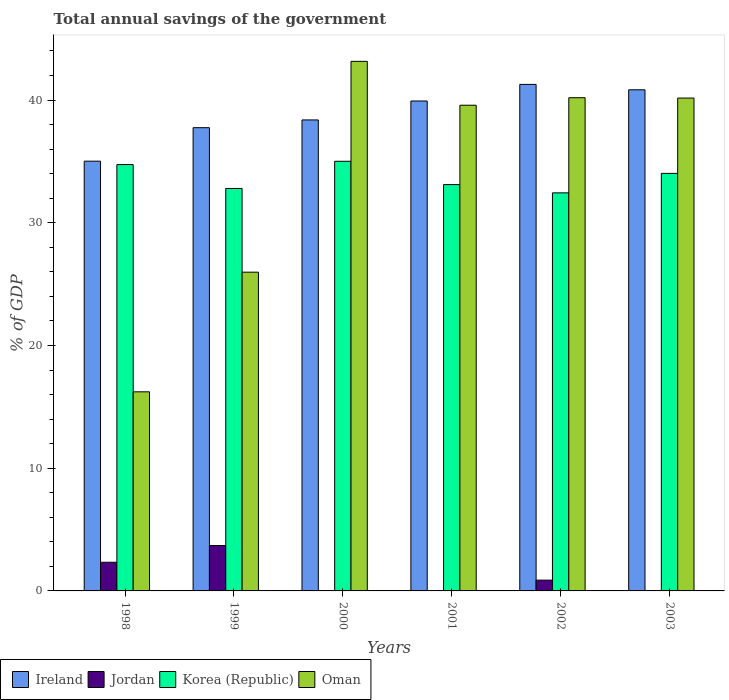How many different coloured bars are there?
Offer a very short reply. 4. How many groups of bars are there?
Make the answer very short. 6. Are the number of bars per tick equal to the number of legend labels?
Ensure brevity in your answer.  No. Are the number of bars on each tick of the X-axis equal?
Offer a very short reply. No. In how many cases, is the number of bars for a given year not equal to the number of legend labels?
Your response must be concise. 3. What is the total annual savings of the government in Oman in 2003?
Offer a very short reply. 40.16. Across all years, what is the maximum total annual savings of the government in Jordan?
Give a very brief answer. 3.7. What is the total total annual savings of the government in Korea (Republic) in the graph?
Ensure brevity in your answer.  202.13. What is the difference between the total annual savings of the government in Oman in 1998 and that in 2000?
Your answer should be compact. -26.93. What is the difference between the total annual savings of the government in Oman in 2003 and the total annual savings of the government in Jordan in 2001?
Your answer should be very brief. 40.16. What is the average total annual savings of the government in Ireland per year?
Your answer should be compact. 38.87. In the year 2002, what is the difference between the total annual savings of the government in Korea (Republic) and total annual savings of the government in Ireland?
Offer a very short reply. -8.84. What is the ratio of the total annual savings of the government in Korea (Republic) in 2000 to that in 2003?
Provide a succinct answer. 1.03. Is the total annual savings of the government in Ireland in 1999 less than that in 2000?
Offer a very short reply. Yes. What is the difference between the highest and the second highest total annual savings of the government in Korea (Republic)?
Provide a short and direct response. 0.27. What is the difference between the highest and the lowest total annual savings of the government in Ireland?
Keep it short and to the point. 6.26. Is it the case that in every year, the sum of the total annual savings of the government in Oman and total annual savings of the government in Jordan is greater than the sum of total annual savings of the government in Ireland and total annual savings of the government in Korea (Republic)?
Ensure brevity in your answer.  No. Is it the case that in every year, the sum of the total annual savings of the government in Korea (Republic) and total annual savings of the government in Jordan is greater than the total annual savings of the government in Oman?
Provide a short and direct response. No. How many bars are there?
Your answer should be very brief. 21. Are all the bars in the graph horizontal?
Provide a short and direct response. No. What is the difference between two consecutive major ticks on the Y-axis?
Your answer should be very brief. 10. Are the values on the major ticks of Y-axis written in scientific E-notation?
Provide a short and direct response. No. Does the graph contain grids?
Ensure brevity in your answer.  No. Where does the legend appear in the graph?
Your answer should be very brief. Bottom left. How many legend labels are there?
Provide a short and direct response. 4. What is the title of the graph?
Your answer should be very brief. Total annual savings of the government. Does "United States" appear as one of the legend labels in the graph?
Keep it short and to the point. No. What is the label or title of the Y-axis?
Provide a succinct answer. % of GDP. What is the % of GDP in Ireland in 1998?
Ensure brevity in your answer.  35.02. What is the % of GDP of Jordan in 1998?
Give a very brief answer. 2.34. What is the % of GDP in Korea (Republic) in 1998?
Your answer should be compact. 34.74. What is the % of GDP in Oman in 1998?
Your answer should be compact. 16.23. What is the % of GDP of Ireland in 1999?
Keep it short and to the point. 37.75. What is the % of GDP of Jordan in 1999?
Give a very brief answer. 3.7. What is the % of GDP of Korea (Republic) in 1999?
Give a very brief answer. 32.8. What is the % of GDP in Oman in 1999?
Your answer should be compact. 25.98. What is the % of GDP of Ireland in 2000?
Offer a very short reply. 38.38. What is the % of GDP of Korea (Republic) in 2000?
Your answer should be very brief. 35.01. What is the % of GDP in Oman in 2000?
Provide a succinct answer. 43.16. What is the % of GDP in Ireland in 2001?
Your response must be concise. 39.92. What is the % of GDP of Jordan in 2001?
Offer a terse response. 0. What is the % of GDP in Korea (Republic) in 2001?
Your response must be concise. 33.11. What is the % of GDP in Oman in 2001?
Offer a very short reply. 39.58. What is the % of GDP in Ireland in 2002?
Your response must be concise. 41.28. What is the % of GDP in Jordan in 2002?
Provide a succinct answer. 0.88. What is the % of GDP of Korea (Republic) in 2002?
Keep it short and to the point. 32.44. What is the % of GDP in Oman in 2002?
Your answer should be very brief. 40.19. What is the % of GDP in Ireland in 2003?
Offer a very short reply. 40.84. What is the % of GDP in Jordan in 2003?
Keep it short and to the point. 0. What is the % of GDP in Korea (Republic) in 2003?
Make the answer very short. 34.03. What is the % of GDP in Oman in 2003?
Provide a short and direct response. 40.16. Across all years, what is the maximum % of GDP of Ireland?
Offer a terse response. 41.28. Across all years, what is the maximum % of GDP in Jordan?
Offer a very short reply. 3.7. Across all years, what is the maximum % of GDP in Korea (Republic)?
Offer a terse response. 35.01. Across all years, what is the maximum % of GDP in Oman?
Your answer should be compact. 43.16. Across all years, what is the minimum % of GDP of Ireland?
Ensure brevity in your answer.  35.02. Across all years, what is the minimum % of GDP of Korea (Republic)?
Your answer should be compact. 32.44. Across all years, what is the minimum % of GDP of Oman?
Offer a terse response. 16.23. What is the total % of GDP in Ireland in the graph?
Your response must be concise. 233.19. What is the total % of GDP in Jordan in the graph?
Provide a short and direct response. 6.92. What is the total % of GDP of Korea (Republic) in the graph?
Your answer should be compact. 202.13. What is the total % of GDP of Oman in the graph?
Keep it short and to the point. 205.29. What is the difference between the % of GDP of Ireland in 1998 and that in 1999?
Provide a succinct answer. -2.73. What is the difference between the % of GDP in Jordan in 1998 and that in 1999?
Keep it short and to the point. -1.37. What is the difference between the % of GDP in Korea (Republic) in 1998 and that in 1999?
Provide a succinct answer. 1.95. What is the difference between the % of GDP in Oman in 1998 and that in 1999?
Offer a terse response. -9.75. What is the difference between the % of GDP in Ireland in 1998 and that in 2000?
Your answer should be compact. -3.36. What is the difference between the % of GDP in Korea (Republic) in 1998 and that in 2000?
Offer a very short reply. -0.27. What is the difference between the % of GDP in Oman in 1998 and that in 2000?
Offer a very short reply. -26.93. What is the difference between the % of GDP in Ireland in 1998 and that in 2001?
Your response must be concise. -4.9. What is the difference between the % of GDP of Korea (Republic) in 1998 and that in 2001?
Ensure brevity in your answer.  1.63. What is the difference between the % of GDP in Oman in 1998 and that in 2001?
Offer a terse response. -23.35. What is the difference between the % of GDP in Ireland in 1998 and that in 2002?
Your answer should be compact. -6.26. What is the difference between the % of GDP of Jordan in 1998 and that in 2002?
Your answer should be compact. 1.46. What is the difference between the % of GDP of Korea (Republic) in 1998 and that in 2002?
Provide a succinct answer. 2.3. What is the difference between the % of GDP of Oman in 1998 and that in 2002?
Provide a short and direct response. -23.97. What is the difference between the % of GDP in Ireland in 1998 and that in 2003?
Keep it short and to the point. -5.82. What is the difference between the % of GDP of Korea (Republic) in 1998 and that in 2003?
Provide a succinct answer. 0.72. What is the difference between the % of GDP of Oman in 1998 and that in 2003?
Your answer should be very brief. -23.94. What is the difference between the % of GDP in Ireland in 1999 and that in 2000?
Ensure brevity in your answer.  -0.63. What is the difference between the % of GDP of Korea (Republic) in 1999 and that in 2000?
Provide a succinct answer. -2.22. What is the difference between the % of GDP in Oman in 1999 and that in 2000?
Your answer should be compact. -17.18. What is the difference between the % of GDP of Ireland in 1999 and that in 2001?
Your response must be concise. -2.17. What is the difference between the % of GDP of Korea (Republic) in 1999 and that in 2001?
Provide a succinct answer. -0.32. What is the difference between the % of GDP in Oman in 1999 and that in 2001?
Keep it short and to the point. -13.6. What is the difference between the % of GDP in Ireland in 1999 and that in 2002?
Give a very brief answer. -3.53. What is the difference between the % of GDP of Jordan in 1999 and that in 2002?
Offer a terse response. 2.82. What is the difference between the % of GDP in Korea (Republic) in 1999 and that in 2002?
Give a very brief answer. 0.36. What is the difference between the % of GDP in Oman in 1999 and that in 2002?
Keep it short and to the point. -14.22. What is the difference between the % of GDP in Ireland in 1999 and that in 2003?
Provide a short and direct response. -3.09. What is the difference between the % of GDP of Korea (Republic) in 1999 and that in 2003?
Your answer should be compact. -1.23. What is the difference between the % of GDP of Oman in 1999 and that in 2003?
Keep it short and to the point. -14.19. What is the difference between the % of GDP of Ireland in 2000 and that in 2001?
Provide a succinct answer. -1.54. What is the difference between the % of GDP of Korea (Republic) in 2000 and that in 2001?
Provide a short and direct response. 1.9. What is the difference between the % of GDP of Oman in 2000 and that in 2001?
Make the answer very short. 3.58. What is the difference between the % of GDP of Ireland in 2000 and that in 2002?
Make the answer very short. -2.9. What is the difference between the % of GDP in Korea (Republic) in 2000 and that in 2002?
Provide a succinct answer. 2.57. What is the difference between the % of GDP in Oman in 2000 and that in 2002?
Provide a short and direct response. 2.96. What is the difference between the % of GDP in Ireland in 2000 and that in 2003?
Provide a succinct answer. -2.46. What is the difference between the % of GDP in Oman in 2000 and that in 2003?
Your answer should be compact. 2.99. What is the difference between the % of GDP in Ireland in 2001 and that in 2002?
Your answer should be very brief. -1.35. What is the difference between the % of GDP of Korea (Republic) in 2001 and that in 2002?
Your response must be concise. 0.67. What is the difference between the % of GDP of Oman in 2001 and that in 2002?
Keep it short and to the point. -0.61. What is the difference between the % of GDP in Ireland in 2001 and that in 2003?
Keep it short and to the point. -0.91. What is the difference between the % of GDP in Korea (Republic) in 2001 and that in 2003?
Give a very brief answer. -0.91. What is the difference between the % of GDP in Oman in 2001 and that in 2003?
Your answer should be very brief. -0.58. What is the difference between the % of GDP of Ireland in 2002 and that in 2003?
Ensure brevity in your answer.  0.44. What is the difference between the % of GDP in Korea (Republic) in 2002 and that in 2003?
Offer a terse response. -1.59. What is the difference between the % of GDP in Oman in 2002 and that in 2003?
Keep it short and to the point. 0.03. What is the difference between the % of GDP in Ireland in 1998 and the % of GDP in Jordan in 1999?
Keep it short and to the point. 31.32. What is the difference between the % of GDP in Ireland in 1998 and the % of GDP in Korea (Republic) in 1999?
Make the answer very short. 2.23. What is the difference between the % of GDP of Ireland in 1998 and the % of GDP of Oman in 1999?
Provide a short and direct response. 9.05. What is the difference between the % of GDP in Jordan in 1998 and the % of GDP in Korea (Republic) in 1999?
Make the answer very short. -30.46. What is the difference between the % of GDP in Jordan in 1998 and the % of GDP in Oman in 1999?
Your answer should be compact. -23.64. What is the difference between the % of GDP in Korea (Republic) in 1998 and the % of GDP in Oman in 1999?
Your answer should be compact. 8.77. What is the difference between the % of GDP in Ireland in 1998 and the % of GDP in Korea (Republic) in 2000?
Provide a succinct answer. 0.01. What is the difference between the % of GDP of Ireland in 1998 and the % of GDP of Oman in 2000?
Your response must be concise. -8.13. What is the difference between the % of GDP of Jordan in 1998 and the % of GDP of Korea (Republic) in 2000?
Give a very brief answer. -32.68. What is the difference between the % of GDP in Jordan in 1998 and the % of GDP in Oman in 2000?
Keep it short and to the point. -40.82. What is the difference between the % of GDP of Korea (Republic) in 1998 and the % of GDP of Oman in 2000?
Your response must be concise. -8.41. What is the difference between the % of GDP of Ireland in 1998 and the % of GDP of Korea (Republic) in 2001?
Ensure brevity in your answer.  1.91. What is the difference between the % of GDP of Ireland in 1998 and the % of GDP of Oman in 2001?
Your answer should be very brief. -4.56. What is the difference between the % of GDP in Jordan in 1998 and the % of GDP in Korea (Republic) in 2001?
Give a very brief answer. -30.78. What is the difference between the % of GDP in Jordan in 1998 and the % of GDP in Oman in 2001?
Provide a succinct answer. -37.24. What is the difference between the % of GDP of Korea (Republic) in 1998 and the % of GDP of Oman in 2001?
Offer a very short reply. -4.84. What is the difference between the % of GDP in Ireland in 1998 and the % of GDP in Jordan in 2002?
Your response must be concise. 34.14. What is the difference between the % of GDP of Ireland in 1998 and the % of GDP of Korea (Republic) in 2002?
Give a very brief answer. 2.58. What is the difference between the % of GDP in Ireland in 1998 and the % of GDP in Oman in 2002?
Offer a very short reply. -5.17. What is the difference between the % of GDP of Jordan in 1998 and the % of GDP of Korea (Republic) in 2002?
Provide a succinct answer. -30.1. What is the difference between the % of GDP in Jordan in 1998 and the % of GDP in Oman in 2002?
Ensure brevity in your answer.  -37.86. What is the difference between the % of GDP of Korea (Republic) in 1998 and the % of GDP of Oman in 2002?
Offer a terse response. -5.45. What is the difference between the % of GDP in Ireland in 1998 and the % of GDP in Korea (Republic) in 2003?
Offer a very short reply. 1. What is the difference between the % of GDP of Ireland in 1998 and the % of GDP of Oman in 2003?
Ensure brevity in your answer.  -5.14. What is the difference between the % of GDP in Jordan in 1998 and the % of GDP in Korea (Republic) in 2003?
Your answer should be very brief. -31.69. What is the difference between the % of GDP of Jordan in 1998 and the % of GDP of Oman in 2003?
Your response must be concise. -37.83. What is the difference between the % of GDP in Korea (Republic) in 1998 and the % of GDP in Oman in 2003?
Make the answer very short. -5.42. What is the difference between the % of GDP of Ireland in 1999 and the % of GDP of Korea (Republic) in 2000?
Offer a terse response. 2.74. What is the difference between the % of GDP in Ireland in 1999 and the % of GDP in Oman in 2000?
Your answer should be compact. -5.4. What is the difference between the % of GDP of Jordan in 1999 and the % of GDP of Korea (Republic) in 2000?
Ensure brevity in your answer.  -31.31. What is the difference between the % of GDP of Jordan in 1999 and the % of GDP of Oman in 2000?
Offer a very short reply. -39.45. What is the difference between the % of GDP in Korea (Republic) in 1999 and the % of GDP in Oman in 2000?
Give a very brief answer. -10.36. What is the difference between the % of GDP of Ireland in 1999 and the % of GDP of Korea (Republic) in 2001?
Keep it short and to the point. 4.64. What is the difference between the % of GDP of Ireland in 1999 and the % of GDP of Oman in 2001?
Ensure brevity in your answer.  -1.83. What is the difference between the % of GDP of Jordan in 1999 and the % of GDP of Korea (Republic) in 2001?
Offer a terse response. -29.41. What is the difference between the % of GDP in Jordan in 1999 and the % of GDP in Oman in 2001?
Your response must be concise. -35.88. What is the difference between the % of GDP of Korea (Republic) in 1999 and the % of GDP of Oman in 2001?
Your answer should be very brief. -6.78. What is the difference between the % of GDP in Ireland in 1999 and the % of GDP in Jordan in 2002?
Offer a very short reply. 36.87. What is the difference between the % of GDP in Ireland in 1999 and the % of GDP in Korea (Republic) in 2002?
Ensure brevity in your answer.  5.31. What is the difference between the % of GDP in Ireland in 1999 and the % of GDP in Oman in 2002?
Your answer should be very brief. -2.44. What is the difference between the % of GDP in Jordan in 1999 and the % of GDP in Korea (Republic) in 2002?
Provide a short and direct response. -28.74. What is the difference between the % of GDP of Jordan in 1999 and the % of GDP of Oman in 2002?
Offer a very short reply. -36.49. What is the difference between the % of GDP of Korea (Republic) in 1999 and the % of GDP of Oman in 2002?
Your answer should be compact. -7.4. What is the difference between the % of GDP in Ireland in 1999 and the % of GDP in Korea (Republic) in 2003?
Your answer should be very brief. 3.72. What is the difference between the % of GDP of Ireland in 1999 and the % of GDP of Oman in 2003?
Your response must be concise. -2.41. What is the difference between the % of GDP of Jordan in 1999 and the % of GDP of Korea (Republic) in 2003?
Offer a terse response. -30.33. What is the difference between the % of GDP in Jordan in 1999 and the % of GDP in Oman in 2003?
Keep it short and to the point. -36.46. What is the difference between the % of GDP in Korea (Republic) in 1999 and the % of GDP in Oman in 2003?
Make the answer very short. -7.37. What is the difference between the % of GDP of Ireland in 2000 and the % of GDP of Korea (Republic) in 2001?
Your response must be concise. 5.27. What is the difference between the % of GDP of Ireland in 2000 and the % of GDP of Oman in 2001?
Ensure brevity in your answer.  -1.2. What is the difference between the % of GDP of Korea (Republic) in 2000 and the % of GDP of Oman in 2001?
Your answer should be very brief. -4.57. What is the difference between the % of GDP of Ireland in 2000 and the % of GDP of Jordan in 2002?
Provide a succinct answer. 37.5. What is the difference between the % of GDP of Ireland in 2000 and the % of GDP of Korea (Republic) in 2002?
Your answer should be compact. 5.94. What is the difference between the % of GDP in Ireland in 2000 and the % of GDP in Oman in 2002?
Provide a succinct answer. -1.81. What is the difference between the % of GDP in Korea (Republic) in 2000 and the % of GDP in Oman in 2002?
Offer a very short reply. -5.18. What is the difference between the % of GDP of Ireland in 2000 and the % of GDP of Korea (Republic) in 2003?
Give a very brief answer. 4.35. What is the difference between the % of GDP of Ireland in 2000 and the % of GDP of Oman in 2003?
Your answer should be very brief. -1.78. What is the difference between the % of GDP of Korea (Republic) in 2000 and the % of GDP of Oman in 2003?
Provide a short and direct response. -5.15. What is the difference between the % of GDP of Ireland in 2001 and the % of GDP of Jordan in 2002?
Make the answer very short. 39.05. What is the difference between the % of GDP of Ireland in 2001 and the % of GDP of Korea (Republic) in 2002?
Offer a very short reply. 7.49. What is the difference between the % of GDP in Ireland in 2001 and the % of GDP in Oman in 2002?
Your answer should be very brief. -0.27. What is the difference between the % of GDP in Korea (Republic) in 2001 and the % of GDP in Oman in 2002?
Your answer should be very brief. -7.08. What is the difference between the % of GDP of Ireland in 2001 and the % of GDP of Korea (Republic) in 2003?
Ensure brevity in your answer.  5.9. What is the difference between the % of GDP in Ireland in 2001 and the % of GDP in Oman in 2003?
Provide a short and direct response. -0.24. What is the difference between the % of GDP of Korea (Republic) in 2001 and the % of GDP of Oman in 2003?
Provide a succinct answer. -7.05. What is the difference between the % of GDP of Ireland in 2002 and the % of GDP of Korea (Republic) in 2003?
Provide a succinct answer. 7.25. What is the difference between the % of GDP in Ireland in 2002 and the % of GDP in Oman in 2003?
Your response must be concise. 1.11. What is the difference between the % of GDP of Jordan in 2002 and the % of GDP of Korea (Republic) in 2003?
Your answer should be compact. -33.15. What is the difference between the % of GDP of Jordan in 2002 and the % of GDP of Oman in 2003?
Give a very brief answer. -39.28. What is the difference between the % of GDP in Korea (Republic) in 2002 and the % of GDP in Oman in 2003?
Provide a succinct answer. -7.72. What is the average % of GDP in Ireland per year?
Offer a very short reply. 38.87. What is the average % of GDP in Jordan per year?
Provide a short and direct response. 1.15. What is the average % of GDP in Korea (Republic) per year?
Keep it short and to the point. 33.69. What is the average % of GDP in Oman per year?
Offer a terse response. 34.22. In the year 1998, what is the difference between the % of GDP of Ireland and % of GDP of Jordan?
Ensure brevity in your answer.  32.69. In the year 1998, what is the difference between the % of GDP in Ireland and % of GDP in Korea (Republic)?
Offer a terse response. 0.28. In the year 1998, what is the difference between the % of GDP in Ireland and % of GDP in Oman?
Provide a short and direct response. 18.8. In the year 1998, what is the difference between the % of GDP in Jordan and % of GDP in Korea (Republic)?
Offer a terse response. -32.41. In the year 1998, what is the difference between the % of GDP in Jordan and % of GDP in Oman?
Offer a very short reply. -13.89. In the year 1998, what is the difference between the % of GDP of Korea (Republic) and % of GDP of Oman?
Your response must be concise. 18.52. In the year 1999, what is the difference between the % of GDP of Ireland and % of GDP of Jordan?
Offer a terse response. 34.05. In the year 1999, what is the difference between the % of GDP of Ireland and % of GDP of Korea (Republic)?
Give a very brief answer. 4.95. In the year 1999, what is the difference between the % of GDP of Ireland and % of GDP of Oman?
Your answer should be very brief. 11.78. In the year 1999, what is the difference between the % of GDP of Jordan and % of GDP of Korea (Republic)?
Provide a succinct answer. -29.1. In the year 1999, what is the difference between the % of GDP in Jordan and % of GDP in Oman?
Your answer should be very brief. -22.27. In the year 1999, what is the difference between the % of GDP in Korea (Republic) and % of GDP in Oman?
Offer a terse response. 6.82. In the year 2000, what is the difference between the % of GDP of Ireland and % of GDP of Korea (Republic)?
Ensure brevity in your answer.  3.37. In the year 2000, what is the difference between the % of GDP in Ireland and % of GDP in Oman?
Provide a short and direct response. -4.77. In the year 2000, what is the difference between the % of GDP of Korea (Republic) and % of GDP of Oman?
Your answer should be compact. -8.14. In the year 2001, what is the difference between the % of GDP of Ireland and % of GDP of Korea (Republic)?
Keep it short and to the point. 6.81. In the year 2001, what is the difference between the % of GDP in Ireland and % of GDP in Oman?
Your answer should be very brief. 0.34. In the year 2001, what is the difference between the % of GDP in Korea (Republic) and % of GDP in Oman?
Keep it short and to the point. -6.47. In the year 2002, what is the difference between the % of GDP in Ireland and % of GDP in Jordan?
Your answer should be very brief. 40.4. In the year 2002, what is the difference between the % of GDP of Ireland and % of GDP of Korea (Republic)?
Ensure brevity in your answer.  8.84. In the year 2002, what is the difference between the % of GDP in Ireland and % of GDP in Oman?
Give a very brief answer. 1.08. In the year 2002, what is the difference between the % of GDP of Jordan and % of GDP of Korea (Republic)?
Ensure brevity in your answer.  -31.56. In the year 2002, what is the difference between the % of GDP in Jordan and % of GDP in Oman?
Offer a terse response. -39.31. In the year 2002, what is the difference between the % of GDP in Korea (Republic) and % of GDP in Oman?
Ensure brevity in your answer.  -7.75. In the year 2003, what is the difference between the % of GDP in Ireland and % of GDP in Korea (Republic)?
Your answer should be very brief. 6.81. In the year 2003, what is the difference between the % of GDP in Ireland and % of GDP in Oman?
Provide a succinct answer. 0.67. In the year 2003, what is the difference between the % of GDP of Korea (Republic) and % of GDP of Oman?
Your answer should be very brief. -6.14. What is the ratio of the % of GDP in Ireland in 1998 to that in 1999?
Keep it short and to the point. 0.93. What is the ratio of the % of GDP in Jordan in 1998 to that in 1999?
Give a very brief answer. 0.63. What is the ratio of the % of GDP in Korea (Republic) in 1998 to that in 1999?
Offer a terse response. 1.06. What is the ratio of the % of GDP in Oman in 1998 to that in 1999?
Keep it short and to the point. 0.62. What is the ratio of the % of GDP of Ireland in 1998 to that in 2000?
Make the answer very short. 0.91. What is the ratio of the % of GDP in Korea (Republic) in 1998 to that in 2000?
Your response must be concise. 0.99. What is the ratio of the % of GDP of Oman in 1998 to that in 2000?
Your answer should be very brief. 0.38. What is the ratio of the % of GDP in Ireland in 1998 to that in 2001?
Your response must be concise. 0.88. What is the ratio of the % of GDP in Korea (Republic) in 1998 to that in 2001?
Provide a succinct answer. 1.05. What is the ratio of the % of GDP of Oman in 1998 to that in 2001?
Your answer should be very brief. 0.41. What is the ratio of the % of GDP of Ireland in 1998 to that in 2002?
Give a very brief answer. 0.85. What is the ratio of the % of GDP of Jordan in 1998 to that in 2002?
Provide a succinct answer. 2.66. What is the ratio of the % of GDP in Korea (Republic) in 1998 to that in 2002?
Keep it short and to the point. 1.07. What is the ratio of the % of GDP in Oman in 1998 to that in 2002?
Provide a succinct answer. 0.4. What is the ratio of the % of GDP of Ireland in 1998 to that in 2003?
Your answer should be very brief. 0.86. What is the ratio of the % of GDP of Korea (Republic) in 1998 to that in 2003?
Make the answer very short. 1.02. What is the ratio of the % of GDP of Oman in 1998 to that in 2003?
Your answer should be very brief. 0.4. What is the ratio of the % of GDP of Ireland in 1999 to that in 2000?
Provide a short and direct response. 0.98. What is the ratio of the % of GDP of Korea (Republic) in 1999 to that in 2000?
Your response must be concise. 0.94. What is the ratio of the % of GDP in Oman in 1999 to that in 2000?
Your response must be concise. 0.6. What is the ratio of the % of GDP of Ireland in 1999 to that in 2001?
Your answer should be compact. 0.95. What is the ratio of the % of GDP of Korea (Republic) in 1999 to that in 2001?
Give a very brief answer. 0.99. What is the ratio of the % of GDP of Oman in 1999 to that in 2001?
Your answer should be compact. 0.66. What is the ratio of the % of GDP of Ireland in 1999 to that in 2002?
Make the answer very short. 0.91. What is the ratio of the % of GDP in Jordan in 1999 to that in 2002?
Keep it short and to the point. 4.21. What is the ratio of the % of GDP in Oman in 1999 to that in 2002?
Your answer should be compact. 0.65. What is the ratio of the % of GDP of Ireland in 1999 to that in 2003?
Your answer should be compact. 0.92. What is the ratio of the % of GDP in Korea (Republic) in 1999 to that in 2003?
Provide a short and direct response. 0.96. What is the ratio of the % of GDP of Oman in 1999 to that in 2003?
Offer a very short reply. 0.65. What is the ratio of the % of GDP in Ireland in 2000 to that in 2001?
Offer a very short reply. 0.96. What is the ratio of the % of GDP in Korea (Republic) in 2000 to that in 2001?
Your response must be concise. 1.06. What is the ratio of the % of GDP in Oman in 2000 to that in 2001?
Give a very brief answer. 1.09. What is the ratio of the % of GDP in Ireland in 2000 to that in 2002?
Keep it short and to the point. 0.93. What is the ratio of the % of GDP in Korea (Republic) in 2000 to that in 2002?
Your response must be concise. 1.08. What is the ratio of the % of GDP in Oman in 2000 to that in 2002?
Your answer should be compact. 1.07. What is the ratio of the % of GDP in Ireland in 2000 to that in 2003?
Your response must be concise. 0.94. What is the ratio of the % of GDP of Korea (Republic) in 2000 to that in 2003?
Offer a very short reply. 1.03. What is the ratio of the % of GDP in Oman in 2000 to that in 2003?
Your response must be concise. 1.07. What is the ratio of the % of GDP of Ireland in 2001 to that in 2002?
Make the answer very short. 0.97. What is the ratio of the % of GDP of Korea (Republic) in 2001 to that in 2002?
Give a very brief answer. 1.02. What is the ratio of the % of GDP in Oman in 2001 to that in 2002?
Make the answer very short. 0.98. What is the ratio of the % of GDP in Ireland in 2001 to that in 2003?
Provide a short and direct response. 0.98. What is the ratio of the % of GDP in Korea (Republic) in 2001 to that in 2003?
Provide a succinct answer. 0.97. What is the ratio of the % of GDP in Oman in 2001 to that in 2003?
Offer a very short reply. 0.99. What is the ratio of the % of GDP in Ireland in 2002 to that in 2003?
Your response must be concise. 1.01. What is the ratio of the % of GDP of Korea (Republic) in 2002 to that in 2003?
Your answer should be very brief. 0.95. What is the ratio of the % of GDP in Oman in 2002 to that in 2003?
Offer a very short reply. 1. What is the difference between the highest and the second highest % of GDP of Ireland?
Make the answer very short. 0.44. What is the difference between the highest and the second highest % of GDP in Jordan?
Your response must be concise. 1.37. What is the difference between the highest and the second highest % of GDP of Korea (Republic)?
Offer a terse response. 0.27. What is the difference between the highest and the second highest % of GDP of Oman?
Provide a succinct answer. 2.96. What is the difference between the highest and the lowest % of GDP in Ireland?
Your response must be concise. 6.26. What is the difference between the highest and the lowest % of GDP of Jordan?
Offer a terse response. 3.7. What is the difference between the highest and the lowest % of GDP in Korea (Republic)?
Ensure brevity in your answer.  2.57. What is the difference between the highest and the lowest % of GDP in Oman?
Keep it short and to the point. 26.93. 